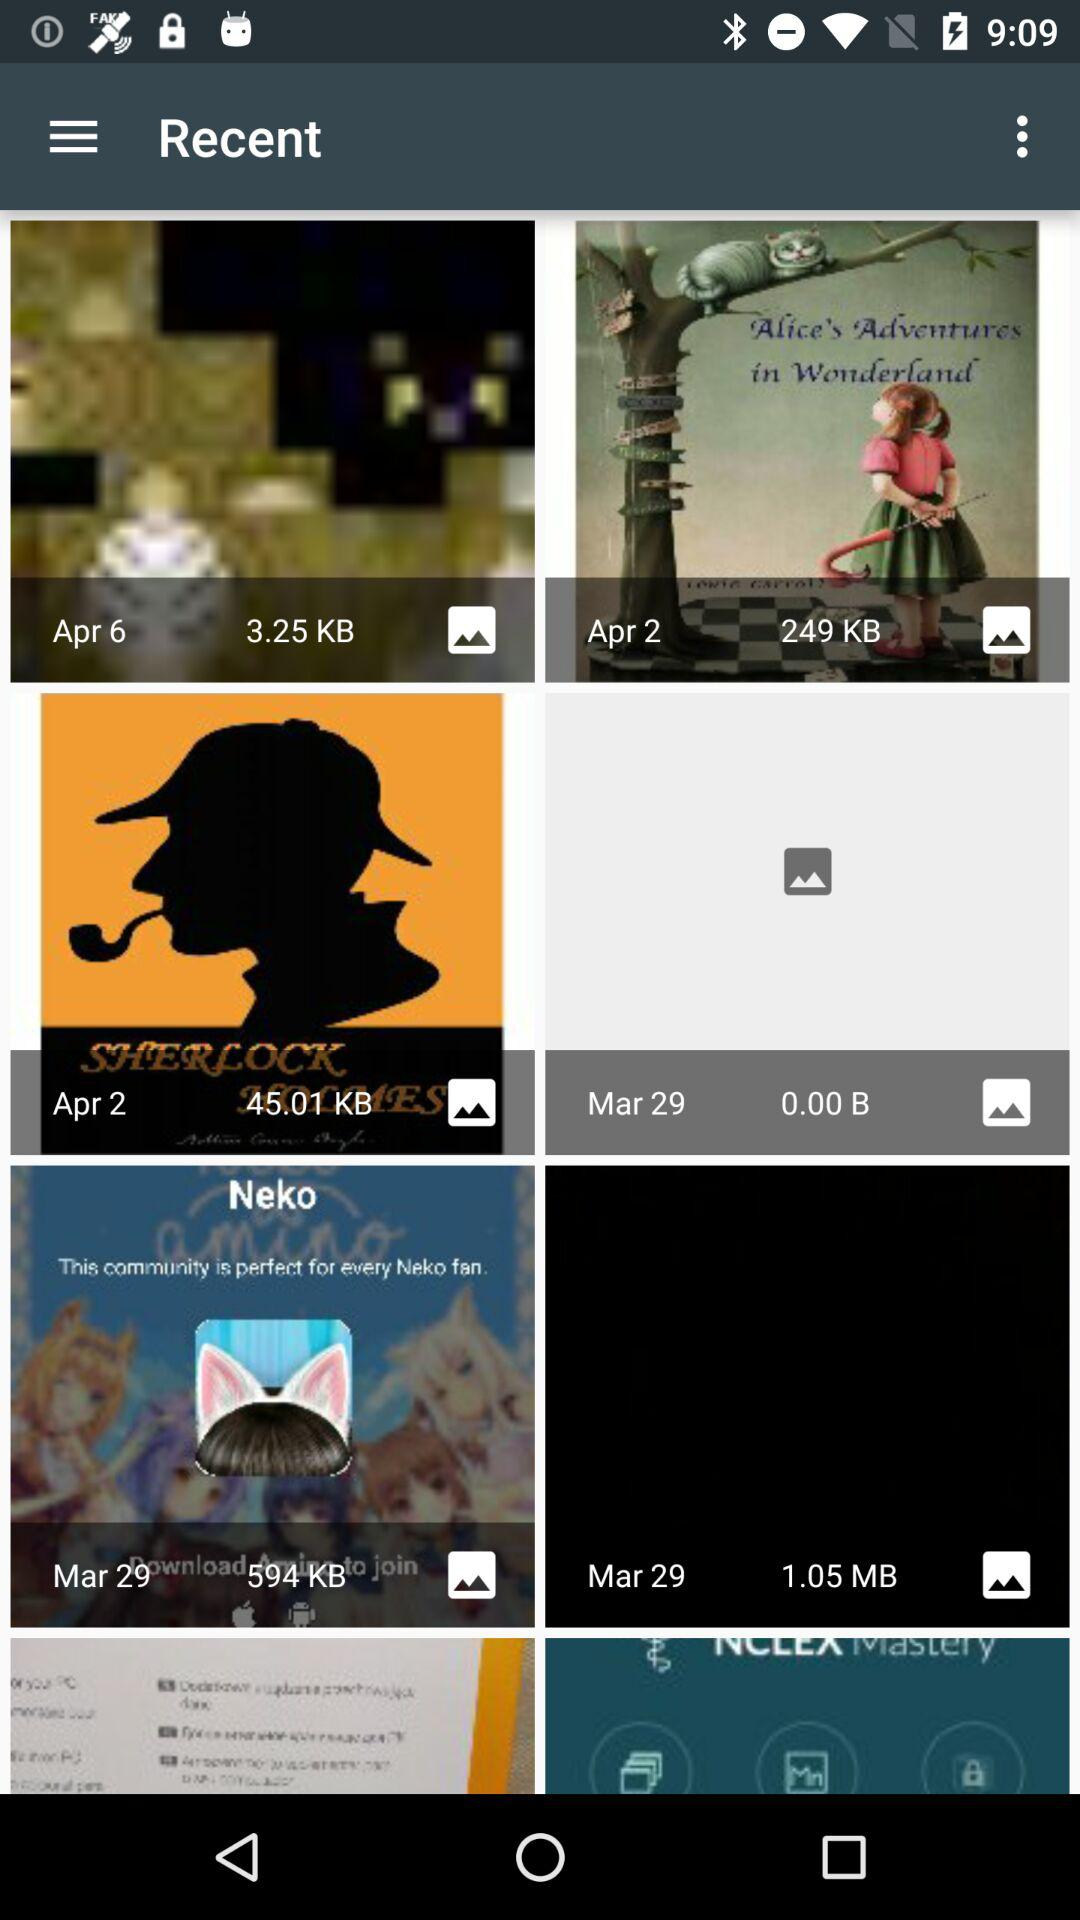When was the image with a file size of 249 KB posted? The image, with a file size of 249 KB, was posted on April 2. 